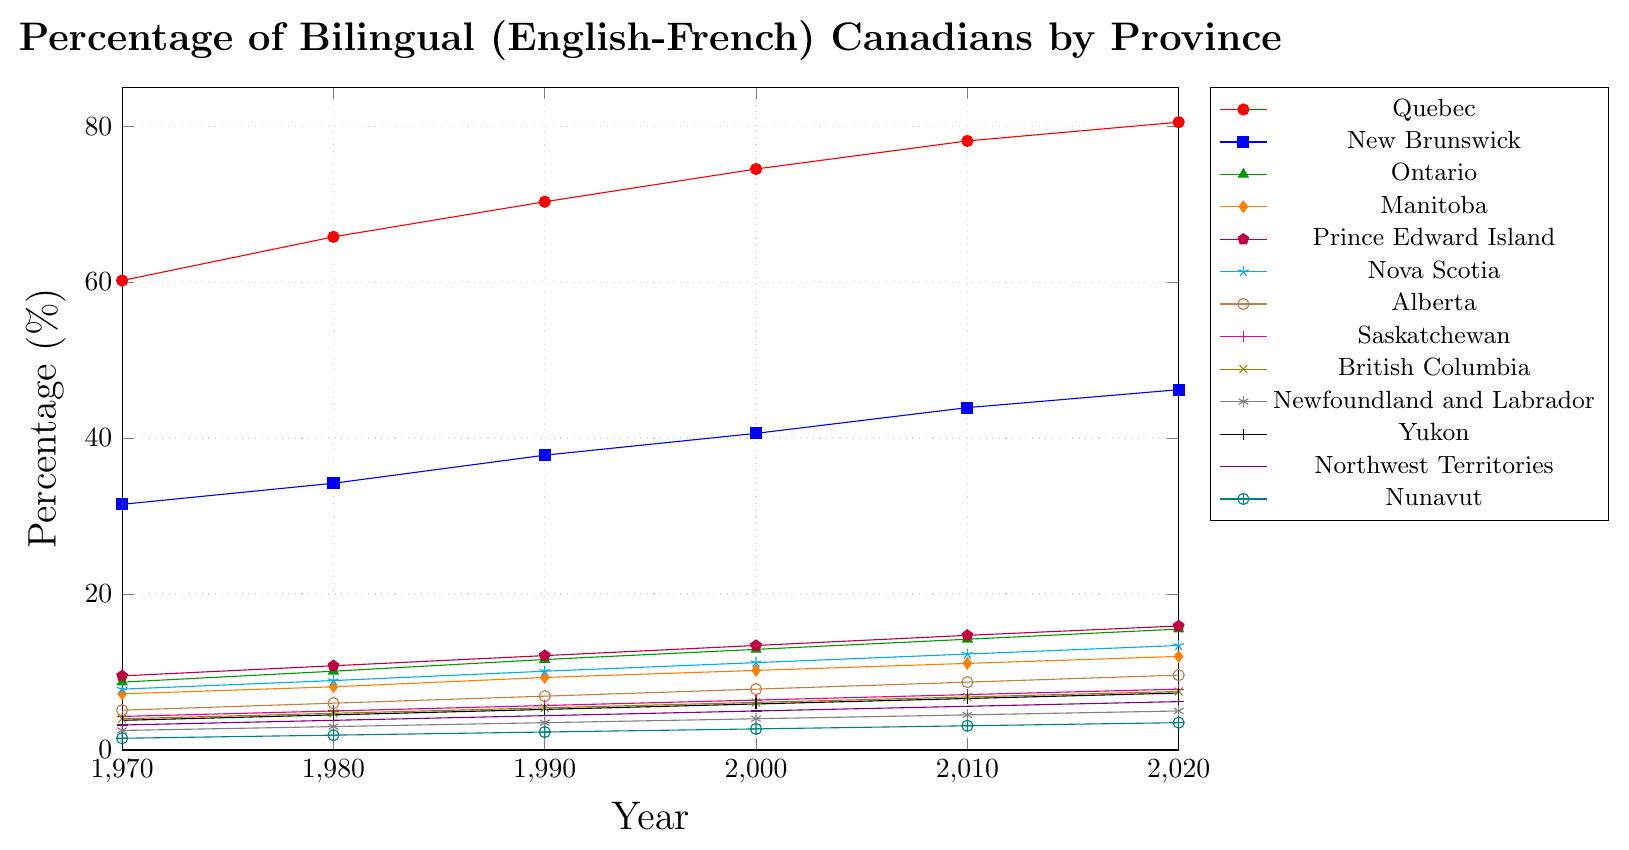Which province had the highest percentage of bilingual Canadians in 2020? Looking at the figure for 2020, Quebec's line is clearly the highest with an endpoint at around 80.5%.
Answer: Quebec How did the percentage of bilingual Canadians in Nova Scotia change from 1970 to 2020? The figure shows Nova Scotia starting at 7.8% in 1970 and increasing to 13.4% in 2020. The change is 13.4 - 7.8.
Answer: 5.6% Which two provinces showed the smallest increase in the percentage of bilingual Canadians from 1970 to 2020? From the figure, Nunavut increased from 1.5% to 3.5% (2% increase), and Newfoundland and Labrador increased from 2.5% to 5.0% (2.5% increase). These are the smallest increments.
Answer: Nunavut and Newfoundland and Labrador What is the average percentage of bilingual Canadians in Ontario across the decades shown? Adding the Ontario percentages: 8.7 + 10.1 + 11.6 + 12.9 + 14.2 + 15.5, the sum is 73, and the average is 73 / 6.
Answer: 12.2% Compare the percentage growth of bilingual Canadians in Alberta and British Columbia from 1970 to 2020. Which one had a higher growth? Alberta grew from 5.1% to 9.6%, an increase of 4.5%. British Columbia grew from 4.0% to 7.5%, an increase of 3.5%. Alberta had a higher growth.
Answer: Alberta Which province had the largest overall increase in bilingual percentage from 1970 to 2020? Quebec increased from 60.2% to 80.5%, an increase of 20.3%, which is the largest.
Answer: Quebec What is the combined percentage of bilingual Canadians in New Brunswick and Manitoba in 2020? New Brunswick is 46.2% and Manitoba is 12.0%. Adding these gives 46.2 + 12.0.
Answer: 58.2% Is there a specific decade where the percentage increase in bilingual Canadians in Quebec was significantly larger compared to other decades? Comparing the slopes in the figure, the increase from 1970 to 1980 is about 65.8 - 60.2 = 5.6, which is significant but increases in other decades are comparably significant too, with steadier growth.
Answer: No, all increases are steady What is the median percentage of bilingual Canadians in New Brunswick for the decades shown? The values for New Brunswick are: 31.5, 34.2, 37.8, 40.6, 43.9, and 46.2. Arranged in order these are still the same. The median is the average of the middle two values: (37.8 + 40.6) / 2 = 39.2.
Answer: 39.2% Which three provinces had the lowest percentage of bilingual Canadians in 2020? Looking at the figure endpoints in 2020, Nunavut (3.5%), Northwest Territories (6.2%), and Newfoundland and Labrador (5.0%) had the lowest.
Answer: Nunavut, Northwest Territories, Newfoundland and Labrador 